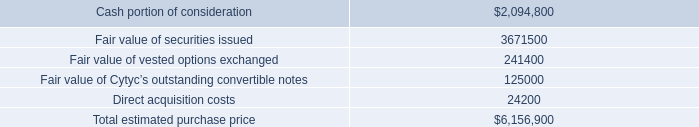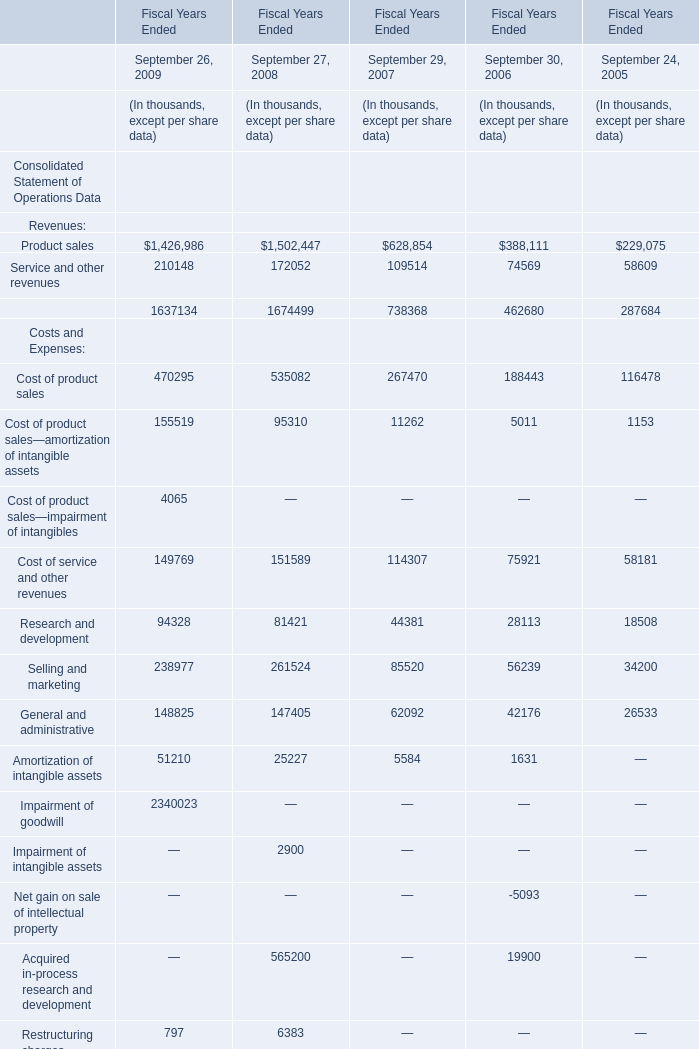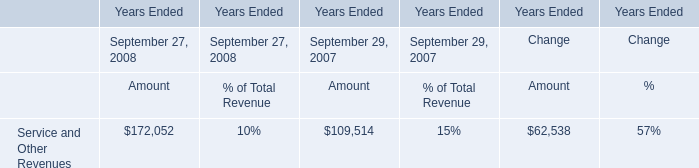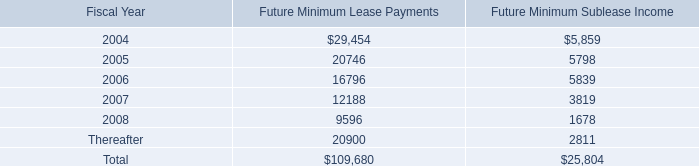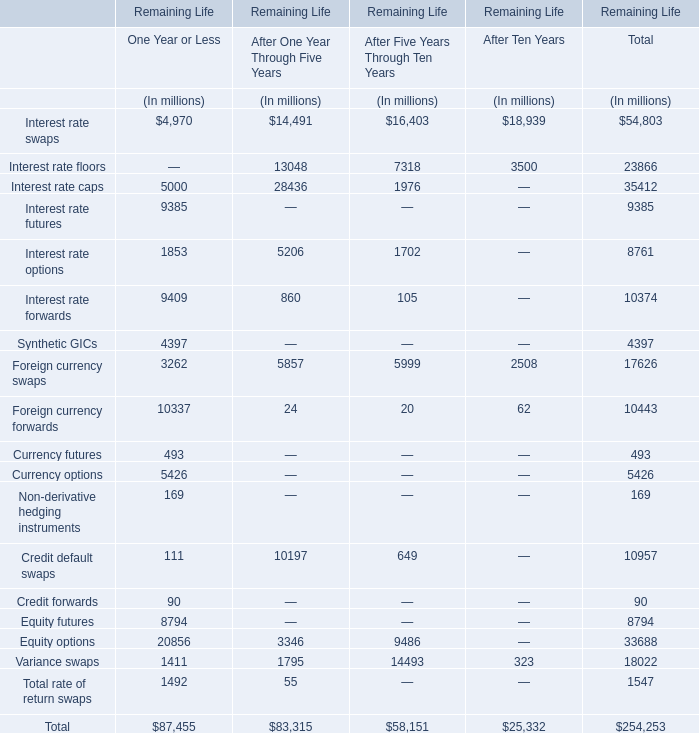What is the growing rate of Service and other revenues in the years with the least Product sales? 
Computations: ((74569 - 58609) / 58609)
Answer: 0.27231. 